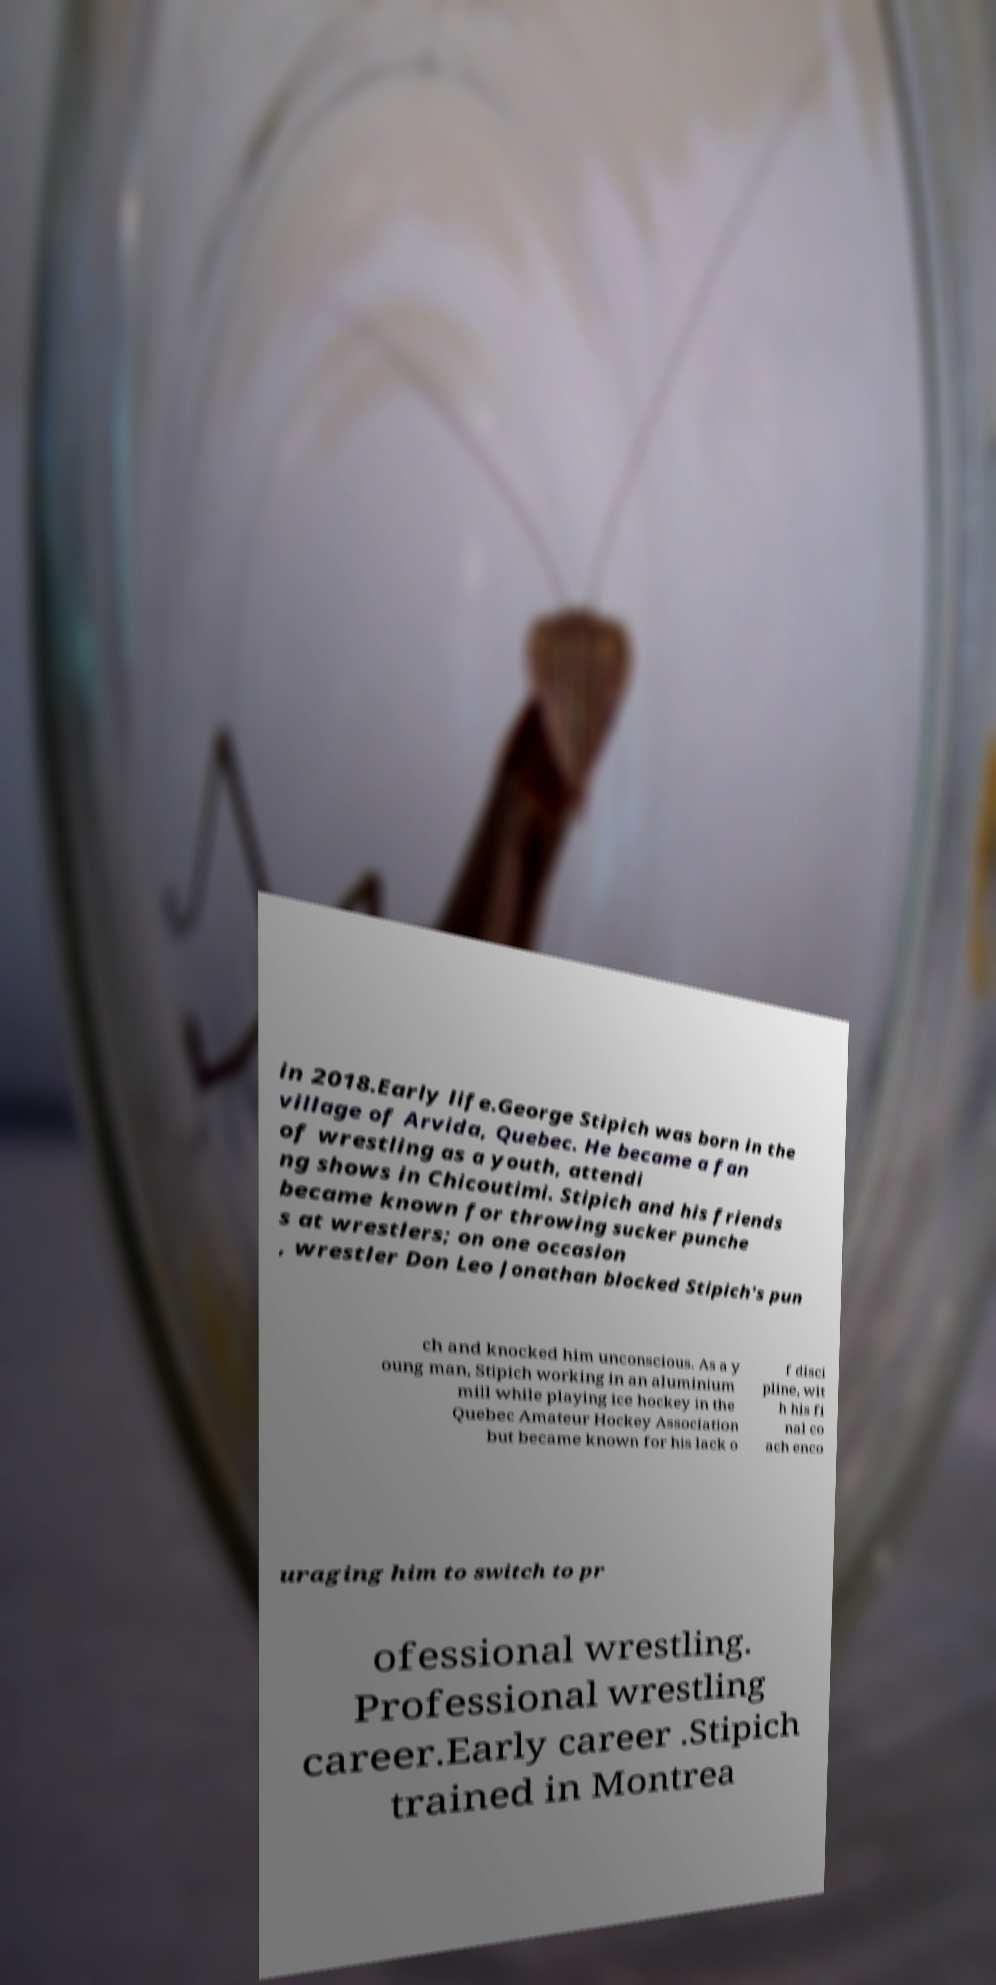What messages or text are displayed in this image? I need them in a readable, typed format. in 2018.Early life.George Stipich was born in the village of Arvida, Quebec. He became a fan of wrestling as a youth, attendi ng shows in Chicoutimi. Stipich and his friends became known for throwing sucker punche s at wrestlers; on one occasion , wrestler Don Leo Jonathan blocked Stipich's pun ch and knocked him unconscious. As a y oung man, Stipich working in an aluminium mill while playing ice hockey in the Quebec Amateur Hockey Association but became known for his lack o f disci pline, wit h his fi nal co ach enco uraging him to switch to pr ofessional wrestling. Professional wrestling career.Early career .Stipich trained in Montrea 